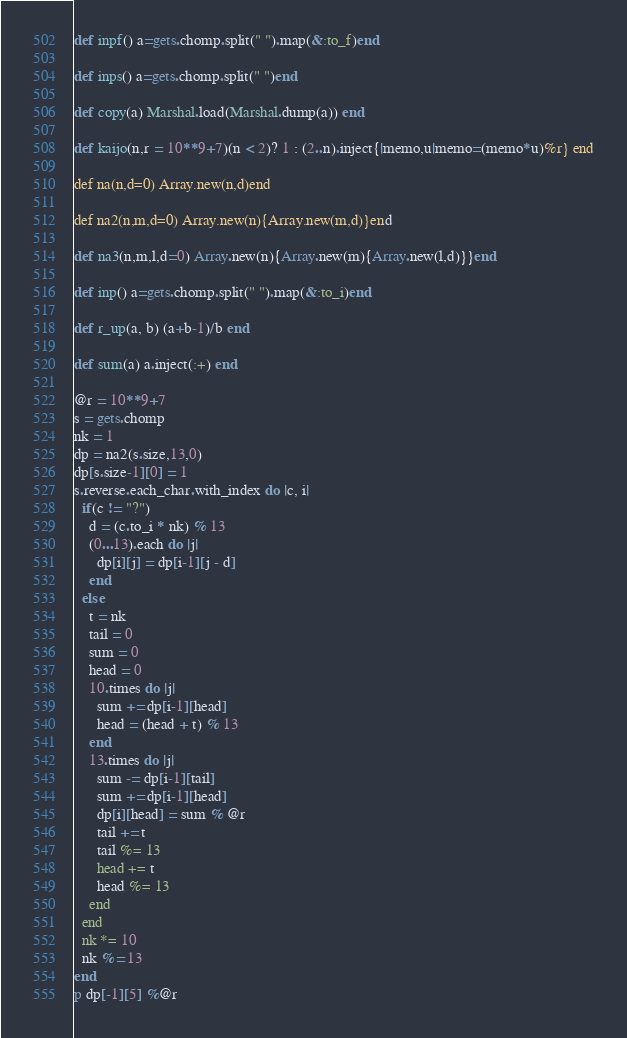Convert code to text. <code><loc_0><loc_0><loc_500><loc_500><_Ruby_>def inpf() a=gets.chomp.split(" ").map(&:to_f)end

def inps() a=gets.chomp.split(" ")end

def copy(a) Marshal.load(Marshal.dump(a)) end

def kaijo(n,r = 10**9+7)(n < 2)? 1 : (2..n).inject{|memo,u|memo=(memo*u)%r} end

def na(n,d=0) Array.new(n,d)end

def na2(n,m,d=0) Array.new(n){Array.new(m,d)}end

def na3(n,m,l,d=0) Array.new(n){Array.new(m){Array.new(l,d)}}end

def inp() a=gets.chomp.split(" ").map(&:to_i)end

def r_up(a, b) (a+b-1)/b end

def sum(a) a.inject(:+) end

@r = 10**9+7
s = gets.chomp
nk = 1
dp = na2(s.size,13,0)
dp[s.size-1][0] = 1
s.reverse.each_char.with_index do |c, i|
  if(c != "?")
    d = (c.to_i * nk) % 13
    (0...13).each do |j|
      dp[i][j] = dp[i-1][j - d]
    end
  else
    t = nk
    tail = 0
    sum = 0
    head = 0
    10.times do |j|
      sum += dp[i-1][head]
      head = (head + t) % 13
    end
    13.times do |j|
      sum -= dp[i-1][tail]
      sum += dp[i-1][head]
      dp[i][head] = sum % @r
      tail += t
      tail %= 13
      head += t
      head %= 13
    end
  end
  nk *= 10
  nk %= 13
end
p dp[-1][5] %@r
</code> 